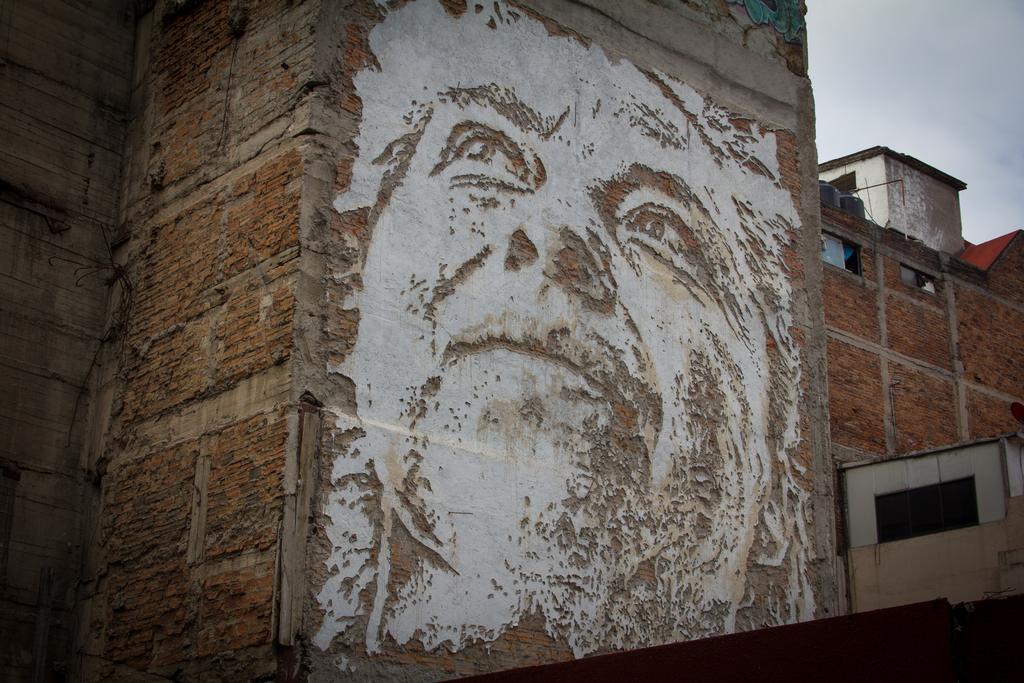In one or two sentences, can you explain what this image depicts? In this picture we can see an image of a person's face on the wall, building, windows, some objects and in the background we can see the sky. 